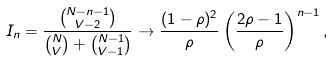<formula> <loc_0><loc_0><loc_500><loc_500>I _ { n } = \frac { \binom { N - n - 1 } { V - 2 } } { \binom { N } { V } + \binom { N - 1 } { V - 1 } } \to \frac { ( 1 - \rho ) ^ { 2 } } { \rho } \left ( \frac { 2 \rho - 1 } { \rho } \right ) ^ { n - 1 } ,</formula> 